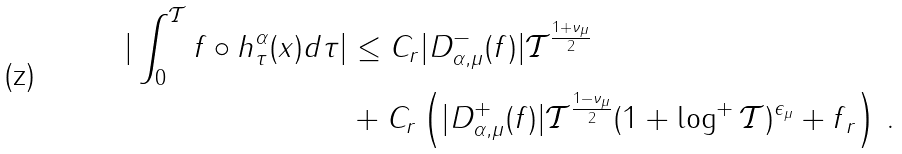Convert formula to latex. <formula><loc_0><loc_0><loc_500><loc_500>| \int _ { 0 } ^ { \mathcal { T } } f \circ h ^ { \alpha } _ { \tau } ( x ) d \tau | & \leq C _ { r } | D ^ { - } _ { \alpha , \mu } ( f ) | \mathcal { T } ^ { \frac { 1 + \nu _ { \mu } } { 2 } } \\ & + C _ { r } \left ( | D ^ { + } _ { \alpha , \mu } ( f ) | \mathcal { T } ^ { \frac { 1 - \nu _ { \mu } } { 2 } } ( 1 + \log ^ { + } { \mathcal { T } } ) ^ { \epsilon _ { \mu } } + \| f \| _ { r } \right ) \, .</formula> 